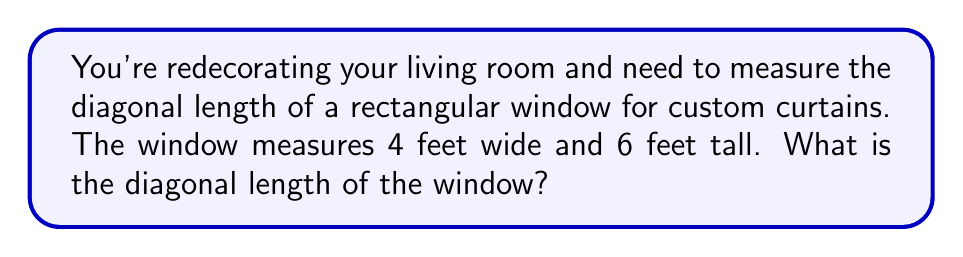What is the answer to this math problem? To find the diagonal length of a rectangular window, we can use the Pythagorean theorem:

1. Let's denote the width as $w$, height as $h$, and diagonal as $d$.

2. According to the Pythagorean theorem: $d^2 = w^2 + h^2$

3. Substitute the given values:
   $d^2 = 4^2 + 6^2$

4. Simplify:
   $d^2 = 16 + 36 = 52$

5. Take the square root of both sides:
   $d = \sqrt{52}$

6. Simplify the square root:
   $d = 2\sqrt{13}$ feet

7. For a decimal approximation:
   $d \approx 7.21$ feet

[asy]
unitsize(20);
draw((0,0)--(4,0)--(4,6)--(0,6)--cycle);
draw((0,0)--(4,6), dashed);
label("4 ft", (2,0), S);
label("6 ft", (4,3), E);
label("d", (2,3), NW);
[/asy]
Answer: $2\sqrt{13}$ feet or approximately 7.21 feet 